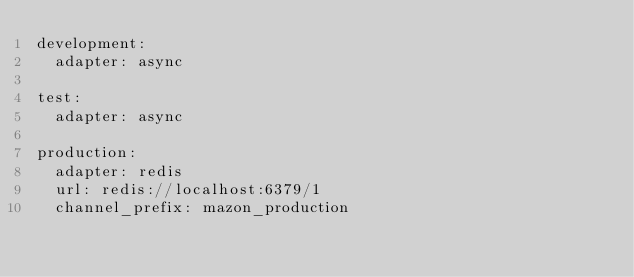<code> <loc_0><loc_0><loc_500><loc_500><_YAML_>development:
  adapter: async

test:
  adapter: async

production:
  adapter: redis
  url: redis://localhost:6379/1
  channel_prefix: mazon_production
</code> 